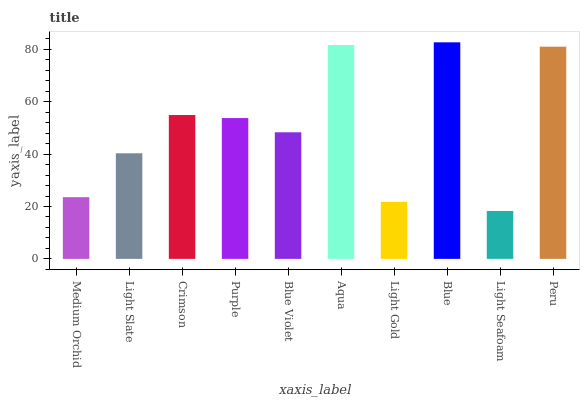Is Light Seafoam the minimum?
Answer yes or no. Yes. Is Blue the maximum?
Answer yes or no. Yes. Is Light Slate the minimum?
Answer yes or no. No. Is Light Slate the maximum?
Answer yes or no. No. Is Light Slate greater than Medium Orchid?
Answer yes or no. Yes. Is Medium Orchid less than Light Slate?
Answer yes or no. Yes. Is Medium Orchid greater than Light Slate?
Answer yes or no. No. Is Light Slate less than Medium Orchid?
Answer yes or no. No. Is Purple the high median?
Answer yes or no. Yes. Is Blue Violet the low median?
Answer yes or no. Yes. Is Light Gold the high median?
Answer yes or no. No. Is Light Seafoam the low median?
Answer yes or no. No. 